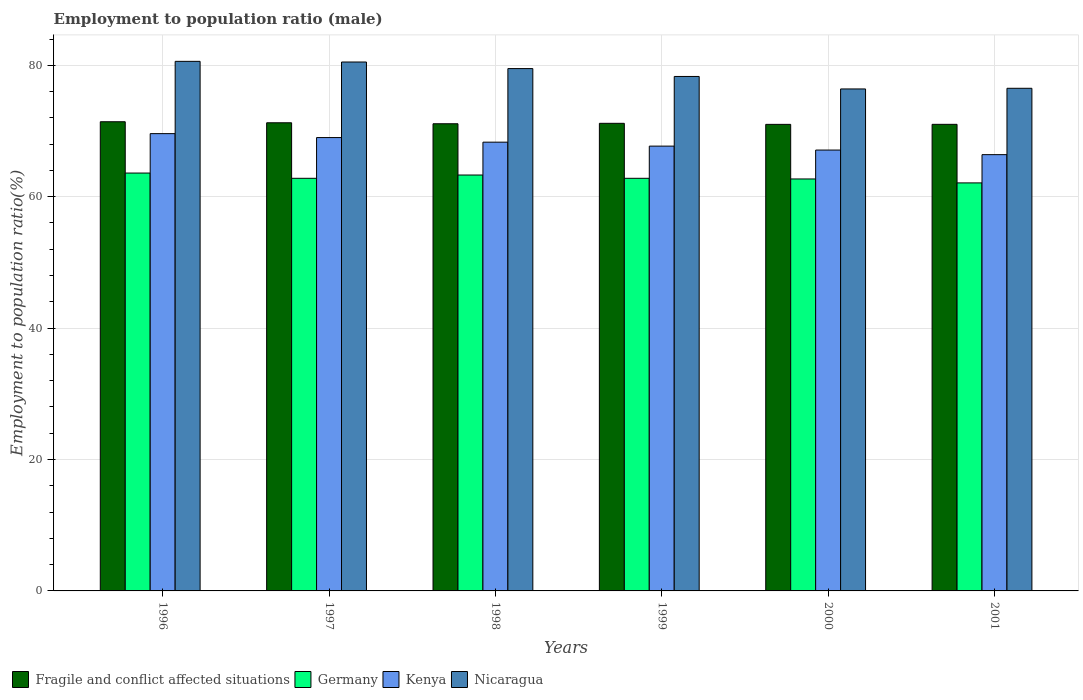How many different coloured bars are there?
Give a very brief answer. 4. How many bars are there on the 2nd tick from the left?
Keep it short and to the point. 4. How many bars are there on the 2nd tick from the right?
Provide a succinct answer. 4. What is the label of the 2nd group of bars from the left?
Your answer should be very brief. 1997. In how many cases, is the number of bars for a given year not equal to the number of legend labels?
Provide a succinct answer. 0. What is the employment to population ratio in Nicaragua in 1998?
Ensure brevity in your answer.  79.5. Across all years, what is the maximum employment to population ratio in Kenya?
Offer a very short reply. 69.6. Across all years, what is the minimum employment to population ratio in Germany?
Keep it short and to the point. 62.1. In which year was the employment to population ratio in Fragile and conflict affected situations maximum?
Provide a short and direct response. 1996. In which year was the employment to population ratio in Germany minimum?
Your response must be concise. 2001. What is the total employment to population ratio in Kenya in the graph?
Keep it short and to the point. 408.1. What is the difference between the employment to population ratio in Fragile and conflict affected situations in 1996 and that in 1998?
Keep it short and to the point. 0.31. What is the difference between the employment to population ratio in Nicaragua in 1996 and the employment to population ratio in Germany in 1999?
Provide a short and direct response. 17.8. What is the average employment to population ratio in Kenya per year?
Ensure brevity in your answer.  68.02. In the year 2001, what is the difference between the employment to population ratio in Fragile and conflict affected situations and employment to population ratio in Kenya?
Your answer should be compact. 4.61. In how many years, is the employment to population ratio in Fragile and conflict affected situations greater than 64 %?
Provide a short and direct response. 6. What is the ratio of the employment to population ratio in Kenya in 1997 to that in 2001?
Provide a succinct answer. 1.04. Is the employment to population ratio in Nicaragua in 1998 less than that in 1999?
Offer a very short reply. No. Is the difference between the employment to population ratio in Fragile and conflict affected situations in 2000 and 2001 greater than the difference between the employment to population ratio in Kenya in 2000 and 2001?
Provide a short and direct response. No. What is the difference between the highest and the second highest employment to population ratio in Nicaragua?
Your answer should be compact. 0.1. Is the sum of the employment to population ratio in Fragile and conflict affected situations in 1997 and 1998 greater than the maximum employment to population ratio in Germany across all years?
Offer a terse response. Yes. What does the 1st bar from the left in 1996 represents?
Provide a succinct answer. Fragile and conflict affected situations. What does the 4th bar from the right in 1997 represents?
Offer a terse response. Fragile and conflict affected situations. Is it the case that in every year, the sum of the employment to population ratio in Kenya and employment to population ratio in Germany is greater than the employment to population ratio in Nicaragua?
Ensure brevity in your answer.  Yes. Are all the bars in the graph horizontal?
Your response must be concise. No. How many years are there in the graph?
Give a very brief answer. 6. What is the difference between two consecutive major ticks on the Y-axis?
Offer a terse response. 20. Does the graph contain grids?
Ensure brevity in your answer.  Yes. Where does the legend appear in the graph?
Your answer should be very brief. Bottom left. How many legend labels are there?
Keep it short and to the point. 4. How are the legend labels stacked?
Your response must be concise. Horizontal. What is the title of the graph?
Your response must be concise. Employment to population ratio (male). Does "Malta" appear as one of the legend labels in the graph?
Keep it short and to the point. No. What is the label or title of the X-axis?
Make the answer very short. Years. What is the Employment to population ratio(%) in Fragile and conflict affected situations in 1996?
Offer a terse response. 71.41. What is the Employment to population ratio(%) of Germany in 1996?
Provide a succinct answer. 63.6. What is the Employment to population ratio(%) of Kenya in 1996?
Provide a short and direct response. 69.6. What is the Employment to population ratio(%) of Nicaragua in 1996?
Make the answer very short. 80.6. What is the Employment to population ratio(%) of Fragile and conflict affected situations in 1997?
Give a very brief answer. 71.25. What is the Employment to population ratio(%) of Germany in 1997?
Provide a succinct answer. 62.8. What is the Employment to population ratio(%) in Nicaragua in 1997?
Offer a very short reply. 80.5. What is the Employment to population ratio(%) in Fragile and conflict affected situations in 1998?
Your answer should be compact. 71.1. What is the Employment to population ratio(%) in Germany in 1998?
Give a very brief answer. 63.3. What is the Employment to population ratio(%) of Kenya in 1998?
Provide a short and direct response. 68.3. What is the Employment to population ratio(%) of Nicaragua in 1998?
Offer a very short reply. 79.5. What is the Employment to population ratio(%) in Fragile and conflict affected situations in 1999?
Offer a very short reply. 71.17. What is the Employment to population ratio(%) of Germany in 1999?
Give a very brief answer. 62.8. What is the Employment to population ratio(%) in Kenya in 1999?
Provide a short and direct response. 67.7. What is the Employment to population ratio(%) in Nicaragua in 1999?
Give a very brief answer. 78.3. What is the Employment to population ratio(%) of Fragile and conflict affected situations in 2000?
Provide a short and direct response. 71.01. What is the Employment to population ratio(%) in Germany in 2000?
Offer a terse response. 62.7. What is the Employment to population ratio(%) in Kenya in 2000?
Make the answer very short. 67.1. What is the Employment to population ratio(%) of Nicaragua in 2000?
Make the answer very short. 76.4. What is the Employment to population ratio(%) of Fragile and conflict affected situations in 2001?
Ensure brevity in your answer.  71.01. What is the Employment to population ratio(%) in Germany in 2001?
Ensure brevity in your answer.  62.1. What is the Employment to population ratio(%) of Kenya in 2001?
Your response must be concise. 66.4. What is the Employment to population ratio(%) in Nicaragua in 2001?
Your response must be concise. 76.5. Across all years, what is the maximum Employment to population ratio(%) in Fragile and conflict affected situations?
Your answer should be compact. 71.41. Across all years, what is the maximum Employment to population ratio(%) of Germany?
Your answer should be compact. 63.6. Across all years, what is the maximum Employment to population ratio(%) of Kenya?
Keep it short and to the point. 69.6. Across all years, what is the maximum Employment to population ratio(%) of Nicaragua?
Offer a very short reply. 80.6. Across all years, what is the minimum Employment to population ratio(%) in Fragile and conflict affected situations?
Ensure brevity in your answer.  71.01. Across all years, what is the minimum Employment to population ratio(%) in Germany?
Your answer should be compact. 62.1. Across all years, what is the minimum Employment to population ratio(%) in Kenya?
Give a very brief answer. 66.4. Across all years, what is the minimum Employment to population ratio(%) in Nicaragua?
Provide a short and direct response. 76.4. What is the total Employment to population ratio(%) of Fragile and conflict affected situations in the graph?
Your answer should be compact. 426.96. What is the total Employment to population ratio(%) of Germany in the graph?
Give a very brief answer. 377.3. What is the total Employment to population ratio(%) in Kenya in the graph?
Provide a short and direct response. 408.1. What is the total Employment to population ratio(%) in Nicaragua in the graph?
Your answer should be compact. 471.8. What is the difference between the Employment to population ratio(%) of Fragile and conflict affected situations in 1996 and that in 1997?
Give a very brief answer. 0.16. What is the difference between the Employment to population ratio(%) in Kenya in 1996 and that in 1997?
Offer a very short reply. 0.6. What is the difference between the Employment to population ratio(%) in Fragile and conflict affected situations in 1996 and that in 1998?
Keep it short and to the point. 0.31. What is the difference between the Employment to population ratio(%) in Fragile and conflict affected situations in 1996 and that in 1999?
Your response must be concise. 0.24. What is the difference between the Employment to population ratio(%) of Kenya in 1996 and that in 1999?
Keep it short and to the point. 1.9. What is the difference between the Employment to population ratio(%) in Nicaragua in 1996 and that in 1999?
Keep it short and to the point. 2.3. What is the difference between the Employment to population ratio(%) in Fragile and conflict affected situations in 1996 and that in 2000?
Offer a terse response. 0.4. What is the difference between the Employment to population ratio(%) in Germany in 1996 and that in 2000?
Provide a succinct answer. 0.9. What is the difference between the Employment to population ratio(%) of Kenya in 1996 and that in 2000?
Your response must be concise. 2.5. What is the difference between the Employment to population ratio(%) of Fragile and conflict affected situations in 1996 and that in 2001?
Provide a short and direct response. 0.39. What is the difference between the Employment to population ratio(%) in Germany in 1996 and that in 2001?
Keep it short and to the point. 1.5. What is the difference between the Employment to population ratio(%) in Kenya in 1996 and that in 2001?
Provide a short and direct response. 3.2. What is the difference between the Employment to population ratio(%) of Nicaragua in 1996 and that in 2001?
Offer a very short reply. 4.1. What is the difference between the Employment to population ratio(%) in Fragile and conflict affected situations in 1997 and that in 1998?
Offer a terse response. 0.15. What is the difference between the Employment to population ratio(%) of Germany in 1997 and that in 1998?
Provide a short and direct response. -0.5. What is the difference between the Employment to population ratio(%) of Kenya in 1997 and that in 1998?
Provide a succinct answer. 0.7. What is the difference between the Employment to population ratio(%) in Fragile and conflict affected situations in 1997 and that in 1999?
Make the answer very short. 0.08. What is the difference between the Employment to population ratio(%) in Kenya in 1997 and that in 1999?
Offer a very short reply. 1.3. What is the difference between the Employment to population ratio(%) of Nicaragua in 1997 and that in 1999?
Provide a short and direct response. 2.2. What is the difference between the Employment to population ratio(%) in Fragile and conflict affected situations in 1997 and that in 2000?
Your answer should be very brief. 0.24. What is the difference between the Employment to population ratio(%) in Germany in 1997 and that in 2000?
Ensure brevity in your answer.  0.1. What is the difference between the Employment to population ratio(%) of Nicaragua in 1997 and that in 2000?
Your answer should be compact. 4.1. What is the difference between the Employment to population ratio(%) in Fragile and conflict affected situations in 1997 and that in 2001?
Offer a terse response. 0.24. What is the difference between the Employment to population ratio(%) of Kenya in 1997 and that in 2001?
Give a very brief answer. 2.6. What is the difference between the Employment to population ratio(%) in Fragile and conflict affected situations in 1998 and that in 1999?
Offer a terse response. -0.07. What is the difference between the Employment to population ratio(%) of Nicaragua in 1998 and that in 1999?
Offer a terse response. 1.2. What is the difference between the Employment to population ratio(%) of Fragile and conflict affected situations in 1998 and that in 2000?
Offer a very short reply. 0.09. What is the difference between the Employment to population ratio(%) of Germany in 1998 and that in 2000?
Ensure brevity in your answer.  0.6. What is the difference between the Employment to population ratio(%) of Kenya in 1998 and that in 2000?
Provide a succinct answer. 1.2. What is the difference between the Employment to population ratio(%) of Nicaragua in 1998 and that in 2000?
Offer a very short reply. 3.1. What is the difference between the Employment to population ratio(%) of Fragile and conflict affected situations in 1998 and that in 2001?
Give a very brief answer. 0.09. What is the difference between the Employment to population ratio(%) in Kenya in 1998 and that in 2001?
Ensure brevity in your answer.  1.9. What is the difference between the Employment to population ratio(%) in Fragile and conflict affected situations in 1999 and that in 2000?
Your answer should be compact. 0.16. What is the difference between the Employment to population ratio(%) of Kenya in 1999 and that in 2000?
Give a very brief answer. 0.6. What is the difference between the Employment to population ratio(%) of Fragile and conflict affected situations in 1999 and that in 2001?
Your answer should be very brief. 0.16. What is the difference between the Employment to population ratio(%) of Germany in 1999 and that in 2001?
Provide a succinct answer. 0.7. What is the difference between the Employment to population ratio(%) of Kenya in 1999 and that in 2001?
Your answer should be very brief. 1.3. What is the difference between the Employment to population ratio(%) in Fragile and conflict affected situations in 2000 and that in 2001?
Make the answer very short. -0. What is the difference between the Employment to population ratio(%) in Germany in 2000 and that in 2001?
Provide a succinct answer. 0.6. What is the difference between the Employment to population ratio(%) of Nicaragua in 2000 and that in 2001?
Provide a succinct answer. -0.1. What is the difference between the Employment to population ratio(%) of Fragile and conflict affected situations in 1996 and the Employment to population ratio(%) of Germany in 1997?
Your answer should be compact. 8.61. What is the difference between the Employment to population ratio(%) of Fragile and conflict affected situations in 1996 and the Employment to population ratio(%) of Kenya in 1997?
Offer a terse response. 2.41. What is the difference between the Employment to population ratio(%) in Fragile and conflict affected situations in 1996 and the Employment to population ratio(%) in Nicaragua in 1997?
Keep it short and to the point. -9.09. What is the difference between the Employment to population ratio(%) in Germany in 1996 and the Employment to population ratio(%) in Nicaragua in 1997?
Provide a succinct answer. -16.9. What is the difference between the Employment to population ratio(%) in Kenya in 1996 and the Employment to population ratio(%) in Nicaragua in 1997?
Your answer should be very brief. -10.9. What is the difference between the Employment to population ratio(%) of Fragile and conflict affected situations in 1996 and the Employment to population ratio(%) of Germany in 1998?
Your answer should be very brief. 8.11. What is the difference between the Employment to population ratio(%) of Fragile and conflict affected situations in 1996 and the Employment to population ratio(%) of Kenya in 1998?
Provide a succinct answer. 3.11. What is the difference between the Employment to population ratio(%) in Fragile and conflict affected situations in 1996 and the Employment to population ratio(%) in Nicaragua in 1998?
Your answer should be compact. -8.09. What is the difference between the Employment to population ratio(%) in Germany in 1996 and the Employment to population ratio(%) in Nicaragua in 1998?
Ensure brevity in your answer.  -15.9. What is the difference between the Employment to population ratio(%) of Kenya in 1996 and the Employment to population ratio(%) of Nicaragua in 1998?
Provide a succinct answer. -9.9. What is the difference between the Employment to population ratio(%) in Fragile and conflict affected situations in 1996 and the Employment to population ratio(%) in Germany in 1999?
Your response must be concise. 8.61. What is the difference between the Employment to population ratio(%) in Fragile and conflict affected situations in 1996 and the Employment to population ratio(%) in Kenya in 1999?
Give a very brief answer. 3.71. What is the difference between the Employment to population ratio(%) of Fragile and conflict affected situations in 1996 and the Employment to population ratio(%) of Nicaragua in 1999?
Ensure brevity in your answer.  -6.89. What is the difference between the Employment to population ratio(%) in Germany in 1996 and the Employment to population ratio(%) in Kenya in 1999?
Ensure brevity in your answer.  -4.1. What is the difference between the Employment to population ratio(%) in Germany in 1996 and the Employment to population ratio(%) in Nicaragua in 1999?
Offer a terse response. -14.7. What is the difference between the Employment to population ratio(%) in Fragile and conflict affected situations in 1996 and the Employment to population ratio(%) in Germany in 2000?
Keep it short and to the point. 8.71. What is the difference between the Employment to population ratio(%) of Fragile and conflict affected situations in 1996 and the Employment to population ratio(%) of Kenya in 2000?
Offer a terse response. 4.31. What is the difference between the Employment to population ratio(%) in Fragile and conflict affected situations in 1996 and the Employment to population ratio(%) in Nicaragua in 2000?
Your response must be concise. -4.99. What is the difference between the Employment to population ratio(%) of Germany in 1996 and the Employment to population ratio(%) of Nicaragua in 2000?
Provide a short and direct response. -12.8. What is the difference between the Employment to population ratio(%) in Kenya in 1996 and the Employment to population ratio(%) in Nicaragua in 2000?
Your response must be concise. -6.8. What is the difference between the Employment to population ratio(%) of Fragile and conflict affected situations in 1996 and the Employment to population ratio(%) of Germany in 2001?
Keep it short and to the point. 9.31. What is the difference between the Employment to population ratio(%) in Fragile and conflict affected situations in 1996 and the Employment to population ratio(%) in Kenya in 2001?
Ensure brevity in your answer.  5.01. What is the difference between the Employment to population ratio(%) in Fragile and conflict affected situations in 1996 and the Employment to population ratio(%) in Nicaragua in 2001?
Provide a short and direct response. -5.09. What is the difference between the Employment to population ratio(%) in Germany in 1996 and the Employment to population ratio(%) in Kenya in 2001?
Offer a very short reply. -2.8. What is the difference between the Employment to population ratio(%) in Germany in 1996 and the Employment to population ratio(%) in Nicaragua in 2001?
Provide a short and direct response. -12.9. What is the difference between the Employment to population ratio(%) in Fragile and conflict affected situations in 1997 and the Employment to population ratio(%) in Germany in 1998?
Ensure brevity in your answer.  7.95. What is the difference between the Employment to population ratio(%) of Fragile and conflict affected situations in 1997 and the Employment to population ratio(%) of Kenya in 1998?
Keep it short and to the point. 2.95. What is the difference between the Employment to population ratio(%) in Fragile and conflict affected situations in 1997 and the Employment to population ratio(%) in Nicaragua in 1998?
Keep it short and to the point. -8.25. What is the difference between the Employment to population ratio(%) in Germany in 1997 and the Employment to population ratio(%) in Kenya in 1998?
Provide a short and direct response. -5.5. What is the difference between the Employment to population ratio(%) of Germany in 1997 and the Employment to population ratio(%) of Nicaragua in 1998?
Your answer should be very brief. -16.7. What is the difference between the Employment to population ratio(%) of Kenya in 1997 and the Employment to population ratio(%) of Nicaragua in 1998?
Your answer should be compact. -10.5. What is the difference between the Employment to population ratio(%) in Fragile and conflict affected situations in 1997 and the Employment to population ratio(%) in Germany in 1999?
Your response must be concise. 8.45. What is the difference between the Employment to population ratio(%) in Fragile and conflict affected situations in 1997 and the Employment to population ratio(%) in Kenya in 1999?
Ensure brevity in your answer.  3.55. What is the difference between the Employment to population ratio(%) of Fragile and conflict affected situations in 1997 and the Employment to population ratio(%) of Nicaragua in 1999?
Offer a very short reply. -7.05. What is the difference between the Employment to population ratio(%) of Germany in 1997 and the Employment to population ratio(%) of Kenya in 1999?
Keep it short and to the point. -4.9. What is the difference between the Employment to population ratio(%) in Germany in 1997 and the Employment to population ratio(%) in Nicaragua in 1999?
Ensure brevity in your answer.  -15.5. What is the difference between the Employment to population ratio(%) of Fragile and conflict affected situations in 1997 and the Employment to population ratio(%) of Germany in 2000?
Make the answer very short. 8.55. What is the difference between the Employment to population ratio(%) in Fragile and conflict affected situations in 1997 and the Employment to population ratio(%) in Kenya in 2000?
Make the answer very short. 4.15. What is the difference between the Employment to population ratio(%) in Fragile and conflict affected situations in 1997 and the Employment to population ratio(%) in Nicaragua in 2000?
Offer a very short reply. -5.15. What is the difference between the Employment to population ratio(%) in Germany in 1997 and the Employment to population ratio(%) in Kenya in 2000?
Your answer should be compact. -4.3. What is the difference between the Employment to population ratio(%) in Fragile and conflict affected situations in 1997 and the Employment to population ratio(%) in Germany in 2001?
Your answer should be very brief. 9.15. What is the difference between the Employment to population ratio(%) of Fragile and conflict affected situations in 1997 and the Employment to population ratio(%) of Kenya in 2001?
Your answer should be compact. 4.85. What is the difference between the Employment to population ratio(%) in Fragile and conflict affected situations in 1997 and the Employment to population ratio(%) in Nicaragua in 2001?
Provide a succinct answer. -5.25. What is the difference between the Employment to population ratio(%) in Germany in 1997 and the Employment to population ratio(%) in Nicaragua in 2001?
Offer a very short reply. -13.7. What is the difference between the Employment to population ratio(%) in Fragile and conflict affected situations in 1998 and the Employment to population ratio(%) in Germany in 1999?
Provide a succinct answer. 8.3. What is the difference between the Employment to population ratio(%) in Fragile and conflict affected situations in 1998 and the Employment to population ratio(%) in Kenya in 1999?
Your response must be concise. 3.4. What is the difference between the Employment to population ratio(%) in Fragile and conflict affected situations in 1998 and the Employment to population ratio(%) in Nicaragua in 1999?
Keep it short and to the point. -7.2. What is the difference between the Employment to population ratio(%) of Kenya in 1998 and the Employment to population ratio(%) of Nicaragua in 1999?
Your answer should be compact. -10. What is the difference between the Employment to population ratio(%) in Fragile and conflict affected situations in 1998 and the Employment to population ratio(%) in Germany in 2000?
Ensure brevity in your answer.  8.4. What is the difference between the Employment to population ratio(%) in Fragile and conflict affected situations in 1998 and the Employment to population ratio(%) in Kenya in 2000?
Offer a very short reply. 4. What is the difference between the Employment to population ratio(%) in Fragile and conflict affected situations in 1998 and the Employment to population ratio(%) in Nicaragua in 2000?
Your answer should be compact. -5.3. What is the difference between the Employment to population ratio(%) of Germany in 1998 and the Employment to population ratio(%) of Kenya in 2000?
Keep it short and to the point. -3.8. What is the difference between the Employment to population ratio(%) in Germany in 1998 and the Employment to population ratio(%) in Nicaragua in 2000?
Make the answer very short. -13.1. What is the difference between the Employment to population ratio(%) of Fragile and conflict affected situations in 1998 and the Employment to population ratio(%) of Germany in 2001?
Give a very brief answer. 9. What is the difference between the Employment to population ratio(%) in Fragile and conflict affected situations in 1998 and the Employment to population ratio(%) in Kenya in 2001?
Give a very brief answer. 4.7. What is the difference between the Employment to population ratio(%) in Fragile and conflict affected situations in 1998 and the Employment to population ratio(%) in Nicaragua in 2001?
Keep it short and to the point. -5.4. What is the difference between the Employment to population ratio(%) in Germany in 1998 and the Employment to population ratio(%) in Kenya in 2001?
Your answer should be very brief. -3.1. What is the difference between the Employment to population ratio(%) in Germany in 1998 and the Employment to population ratio(%) in Nicaragua in 2001?
Provide a succinct answer. -13.2. What is the difference between the Employment to population ratio(%) of Fragile and conflict affected situations in 1999 and the Employment to population ratio(%) of Germany in 2000?
Your answer should be very brief. 8.47. What is the difference between the Employment to population ratio(%) in Fragile and conflict affected situations in 1999 and the Employment to population ratio(%) in Kenya in 2000?
Offer a terse response. 4.07. What is the difference between the Employment to population ratio(%) of Fragile and conflict affected situations in 1999 and the Employment to population ratio(%) of Nicaragua in 2000?
Keep it short and to the point. -5.23. What is the difference between the Employment to population ratio(%) of Germany in 1999 and the Employment to population ratio(%) of Kenya in 2000?
Offer a terse response. -4.3. What is the difference between the Employment to population ratio(%) of Germany in 1999 and the Employment to population ratio(%) of Nicaragua in 2000?
Keep it short and to the point. -13.6. What is the difference between the Employment to population ratio(%) of Fragile and conflict affected situations in 1999 and the Employment to population ratio(%) of Germany in 2001?
Your response must be concise. 9.07. What is the difference between the Employment to population ratio(%) of Fragile and conflict affected situations in 1999 and the Employment to population ratio(%) of Kenya in 2001?
Provide a succinct answer. 4.77. What is the difference between the Employment to population ratio(%) in Fragile and conflict affected situations in 1999 and the Employment to population ratio(%) in Nicaragua in 2001?
Make the answer very short. -5.33. What is the difference between the Employment to population ratio(%) of Germany in 1999 and the Employment to population ratio(%) of Kenya in 2001?
Offer a very short reply. -3.6. What is the difference between the Employment to population ratio(%) in Germany in 1999 and the Employment to population ratio(%) in Nicaragua in 2001?
Your answer should be very brief. -13.7. What is the difference between the Employment to population ratio(%) of Kenya in 1999 and the Employment to population ratio(%) of Nicaragua in 2001?
Make the answer very short. -8.8. What is the difference between the Employment to population ratio(%) in Fragile and conflict affected situations in 2000 and the Employment to population ratio(%) in Germany in 2001?
Make the answer very short. 8.91. What is the difference between the Employment to population ratio(%) in Fragile and conflict affected situations in 2000 and the Employment to population ratio(%) in Kenya in 2001?
Your response must be concise. 4.61. What is the difference between the Employment to population ratio(%) of Fragile and conflict affected situations in 2000 and the Employment to population ratio(%) of Nicaragua in 2001?
Ensure brevity in your answer.  -5.49. What is the difference between the Employment to population ratio(%) in Germany in 2000 and the Employment to population ratio(%) in Kenya in 2001?
Offer a terse response. -3.7. What is the difference between the Employment to population ratio(%) of Germany in 2000 and the Employment to population ratio(%) of Nicaragua in 2001?
Provide a succinct answer. -13.8. What is the difference between the Employment to population ratio(%) of Kenya in 2000 and the Employment to population ratio(%) of Nicaragua in 2001?
Offer a terse response. -9.4. What is the average Employment to population ratio(%) of Fragile and conflict affected situations per year?
Your response must be concise. 71.16. What is the average Employment to population ratio(%) in Germany per year?
Your answer should be compact. 62.88. What is the average Employment to population ratio(%) of Kenya per year?
Offer a terse response. 68.02. What is the average Employment to population ratio(%) of Nicaragua per year?
Provide a succinct answer. 78.63. In the year 1996, what is the difference between the Employment to population ratio(%) of Fragile and conflict affected situations and Employment to population ratio(%) of Germany?
Make the answer very short. 7.81. In the year 1996, what is the difference between the Employment to population ratio(%) of Fragile and conflict affected situations and Employment to population ratio(%) of Kenya?
Make the answer very short. 1.81. In the year 1996, what is the difference between the Employment to population ratio(%) in Fragile and conflict affected situations and Employment to population ratio(%) in Nicaragua?
Keep it short and to the point. -9.19. In the year 1997, what is the difference between the Employment to population ratio(%) of Fragile and conflict affected situations and Employment to population ratio(%) of Germany?
Ensure brevity in your answer.  8.45. In the year 1997, what is the difference between the Employment to population ratio(%) in Fragile and conflict affected situations and Employment to population ratio(%) in Kenya?
Make the answer very short. 2.25. In the year 1997, what is the difference between the Employment to population ratio(%) in Fragile and conflict affected situations and Employment to population ratio(%) in Nicaragua?
Your answer should be compact. -9.25. In the year 1997, what is the difference between the Employment to population ratio(%) in Germany and Employment to population ratio(%) in Nicaragua?
Give a very brief answer. -17.7. In the year 1998, what is the difference between the Employment to population ratio(%) of Fragile and conflict affected situations and Employment to population ratio(%) of Germany?
Make the answer very short. 7.8. In the year 1998, what is the difference between the Employment to population ratio(%) in Fragile and conflict affected situations and Employment to population ratio(%) in Kenya?
Offer a terse response. 2.8. In the year 1998, what is the difference between the Employment to population ratio(%) in Fragile and conflict affected situations and Employment to population ratio(%) in Nicaragua?
Give a very brief answer. -8.4. In the year 1998, what is the difference between the Employment to population ratio(%) in Germany and Employment to population ratio(%) in Nicaragua?
Offer a terse response. -16.2. In the year 1998, what is the difference between the Employment to population ratio(%) of Kenya and Employment to population ratio(%) of Nicaragua?
Offer a terse response. -11.2. In the year 1999, what is the difference between the Employment to population ratio(%) of Fragile and conflict affected situations and Employment to population ratio(%) of Germany?
Offer a very short reply. 8.37. In the year 1999, what is the difference between the Employment to population ratio(%) in Fragile and conflict affected situations and Employment to population ratio(%) in Kenya?
Your answer should be compact. 3.47. In the year 1999, what is the difference between the Employment to population ratio(%) of Fragile and conflict affected situations and Employment to population ratio(%) of Nicaragua?
Your answer should be compact. -7.13. In the year 1999, what is the difference between the Employment to population ratio(%) in Germany and Employment to population ratio(%) in Nicaragua?
Keep it short and to the point. -15.5. In the year 1999, what is the difference between the Employment to population ratio(%) of Kenya and Employment to population ratio(%) of Nicaragua?
Offer a terse response. -10.6. In the year 2000, what is the difference between the Employment to population ratio(%) in Fragile and conflict affected situations and Employment to population ratio(%) in Germany?
Make the answer very short. 8.31. In the year 2000, what is the difference between the Employment to population ratio(%) of Fragile and conflict affected situations and Employment to population ratio(%) of Kenya?
Provide a succinct answer. 3.91. In the year 2000, what is the difference between the Employment to population ratio(%) in Fragile and conflict affected situations and Employment to population ratio(%) in Nicaragua?
Offer a terse response. -5.39. In the year 2000, what is the difference between the Employment to population ratio(%) of Germany and Employment to population ratio(%) of Nicaragua?
Keep it short and to the point. -13.7. In the year 2001, what is the difference between the Employment to population ratio(%) in Fragile and conflict affected situations and Employment to population ratio(%) in Germany?
Offer a very short reply. 8.91. In the year 2001, what is the difference between the Employment to population ratio(%) of Fragile and conflict affected situations and Employment to population ratio(%) of Kenya?
Make the answer very short. 4.61. In the year 2001, what is the difference between the Employment to population ratio(%) in Fragile and conflict affected situations and Employment to population ratio(%) in Nicaragua?
Keep it short and to the point. -5.49. In the year 2001, what is the difference between the Employment to population ratio(%) in Germany and Employment to population ratio(%) in Kenya?
Keep it short and to the point. -4.3. In the year 2001, what is the difference between the Employment to population ratio(%) of Germany and Employment to population ratio(%) of Nicaragua?
Provide a succinct answer. -14.4. In the year 2001, what is the difference between the Employment to population ratio(%) in Kenya and Employment to population ratio(%) in Nicaragua?
Ensure brevity in your answer.  -10.1. What is the ratio of the Employment to population ratio(%) of Fragile and conflict affected situations in 1996 to that in 1997?
Your answer should be compact. 1. What is the ratio of the Employment to population ratio(%) of Germany in 1996 to that in 1997?
Your response must be concise. 1.01. What is the ratio of the Employment to population ratio(%) of Kenya in 1996 to that in 1997?
Offer a very short reply. 1.01. What is the ratio of the Employment to population ratio(%) of Germany in 1996 to that in 1998?
Make the answer very short. 1. What is the ratio of the Employment to population ratio(%) in Nicaragua in 1996 to that in 1998?
Your response must be concise. 1.01. What is the ratio of the Employment to population ratio(%) in Germany in 1996 to that in 1999?
Your response must be concise. 1.01. What is the ratio of the Employment to population ratio(%) in Kenya in 1996 to that in 1999?
Keep it short and to the point. 1.03. What is the ratio of the Employment to population ratio(%) of Nicaragua in 1996 to that in 1999?
Offer a terse response. 1.03. What is the ratio of the Employment to population ratio(%) of Fragile and conflict affected situations in 1996 to that in 2000?
Ensure brevity in your answer.  1.01. What is the ratio of the Employment to population ratio(%) in Germany in 1996 to that in 2000?
Your answer should be very brief. 1.01. What is the ratio of the Employment to population ratio(%) of Kenya in 1996 to that in 2000?
Provide a succinct answer. 1.04. What is the ratio of the Employment to population ratio(%) in Nicaragua in 1996 to that in 2000?
Keep it short and to the point. 1.05. What is the ratio of the Employment to population ratio(%) of Fragile and conflict affected situations in 1996 to that in 2001?
Your answer should be compact. 1.01. What is the ratio of the Employment to population ratio(%) in Germany in 1996 to that in 2001?
Give a very brief answer. 1.02. What is the ratio of the Employment to population ratio(%) in Kenya in 1996 to that in 2001?
Give a very brief answer. 1.05. What is the ratio of the Employment to population ratio(%) in Nicaragua in 1996 to that in 2001?
Keep it short and to the point. 1.05. What is the ratio of the Employment to population ratio(%) in Fragile and conflict affected situations in 1997 to that in 1998?
Ensure brevity in your answer.  1. What is the ratio of the Employment to population ratio(%) of Germany in 1997 to that in 1998?
Provide a short and direct response. 0.99. What is the ratio of the Employment to population ratio(%) of Kenya in 1997 to that in 1998?
Your answer should be compact. 1.01. What is the ratio of the Employment to population ratio(%) in Nicaragua in 1997 to that in 1998?
Your answer should be very brief. 1.01. What is the ratio of the Employment to population ratio(%) in Germany in 1997 to that in 1999?
Provide a succinct answer. 1. What is the ratio of the Employment to population ratio(%) of Kenya in 1997 to that in 1999?
Provide a short and direct response. 1.02. What is the ratio of the Employment to population ratio(%) in Nicaragua in 1997 to that in 1999?
Provide a succinct answer. 1.03. What is the ratio of the Employment to population ratio(%) of Germany in 1997 to that in 2000?
Offer a very short reply. 1. What is the ratio of the Employment to population ratio(%) of Kenya in 1997 to that in 2000?
Offer a very short reply. 1.03. What is the ratio of the Employment to population ratio(%) of Nicaragua in 1997 to that in 2000?
Offer a very short reply. 1.05. What is the ratio of the Employment to population ratio(%) of Germany in 1997 to that in 2001?
Ensure brevity in your answer.  1.01. What is the ratio of the Employment to population ratio(%) of Kenya in 1997 to that in 2001?
Give a very brief answer. 1.04. What is the ratio of the Employment to population ratio(%) of Nicaragua in 1997 to that in 2001?
Provide a succinct answer. 1.05. What is the ratio of the Employment to population ratio(%) in Germany in 1998 to that in 1999?
Your answer should be very brief. 1.01. What is the ratio of the Employment to population ratio(%) in Kenya in 1998 to that in 1999?
Your answer should be compact. 1.01. What is the ratio of the Employment to population ratio(%) of Nicaragua in 1998 to that in 1999?
Offer a very short reply. 1.02. What is the ratio of the Employment to population ratio(%) of Germany in 1998 to that in 2000?
Give a very brief answer. 1.01. What is the ratio of the Employment to population ratio(%) of Kenya in 1998 to that in 2000?
Offer a very short reply. 1.02. What is the ratio of the Employment to population ratio(%) of Nicaragua in 1998 to that in 2000?
Keep it short and to the point. 1.04. What is the ratio of the Employment to population ratio(%) of Fragile and conflict affected situations in 1998 to that in 2001?
Make the answer very short. 1. What is the ratio of the Employment to population ratio(%) in Germany in 1998 to that in 2001?
Your response must be concise. 1.02. What is the ratio of the Employment to population ratio(%) in Kenya in 1998 to that in 2001?
Ensure brevity in your answer.  1.03. What is the ratio of the Employment to population ratio(%) of Nicaragua in 1998 to that in 2001?
Offer a terse response. 1.04. What is the ratio of the Employment to population ratio(%) in Fragile and conflict affected situations in 1999 to that in 2000?
Offer a very short reply. 1. What is the ratio of the Employment to population ratio(%) in Kenya in 1999 to that in 2000?
Offer a very short reply. 1.01. What is the ratio of the Employment to population ratio(%) of Nicaragua in 1999 to that in 2000?
Provide a short and direct response. 1.02. What is the ratio of the Employment to population ratio(%) in Fragile and conflict affected situations in 1999 to that in 2001?
Offer a very short reply. 1. What is the ratio of the Employment to population ratio(%) in Germany in 1999 to that in 2001?
Provide a succinct answer. 1.01. What is the ratio of the Employment to population ratio(%) in Kenya in 1999 to that in 2001?
Your answer should be compact. 1.02. What is the ratio of the Employment to population ratio(%) of Nicaragua in 1999 to that in 2001?
Keep it short and to the point. 1.02. What is the ratio of the Employment to population ratio(%) in Fragile and conflict affected situations in 2000 to that in 2001?
Ensure brevity in your answer.  1. What is the ratio of the Employment to population ratio(%) of Germany in 2000 to that in 2001?
Provide a succinct answer. 1.01. What is the ratio of the Employment to population ratio(%) in Kenya in 2000 to that in 2001?
Offer a very short reply. 1.01. What is the difference between the highest and the second highest Employment to population ratio(%) of Fragile and conflict affected situations?
Provide a short and direct response. 0.16. What is the difference between the highest and the lowest Employment to population ratio(%) of Fragile and conflict affected situations?
Your response must be concise. 0.4. What is the difference between the highest and the lowest Employment to population ratio(%) of Nicaragua?
Your answer should be compact. 4.2. 